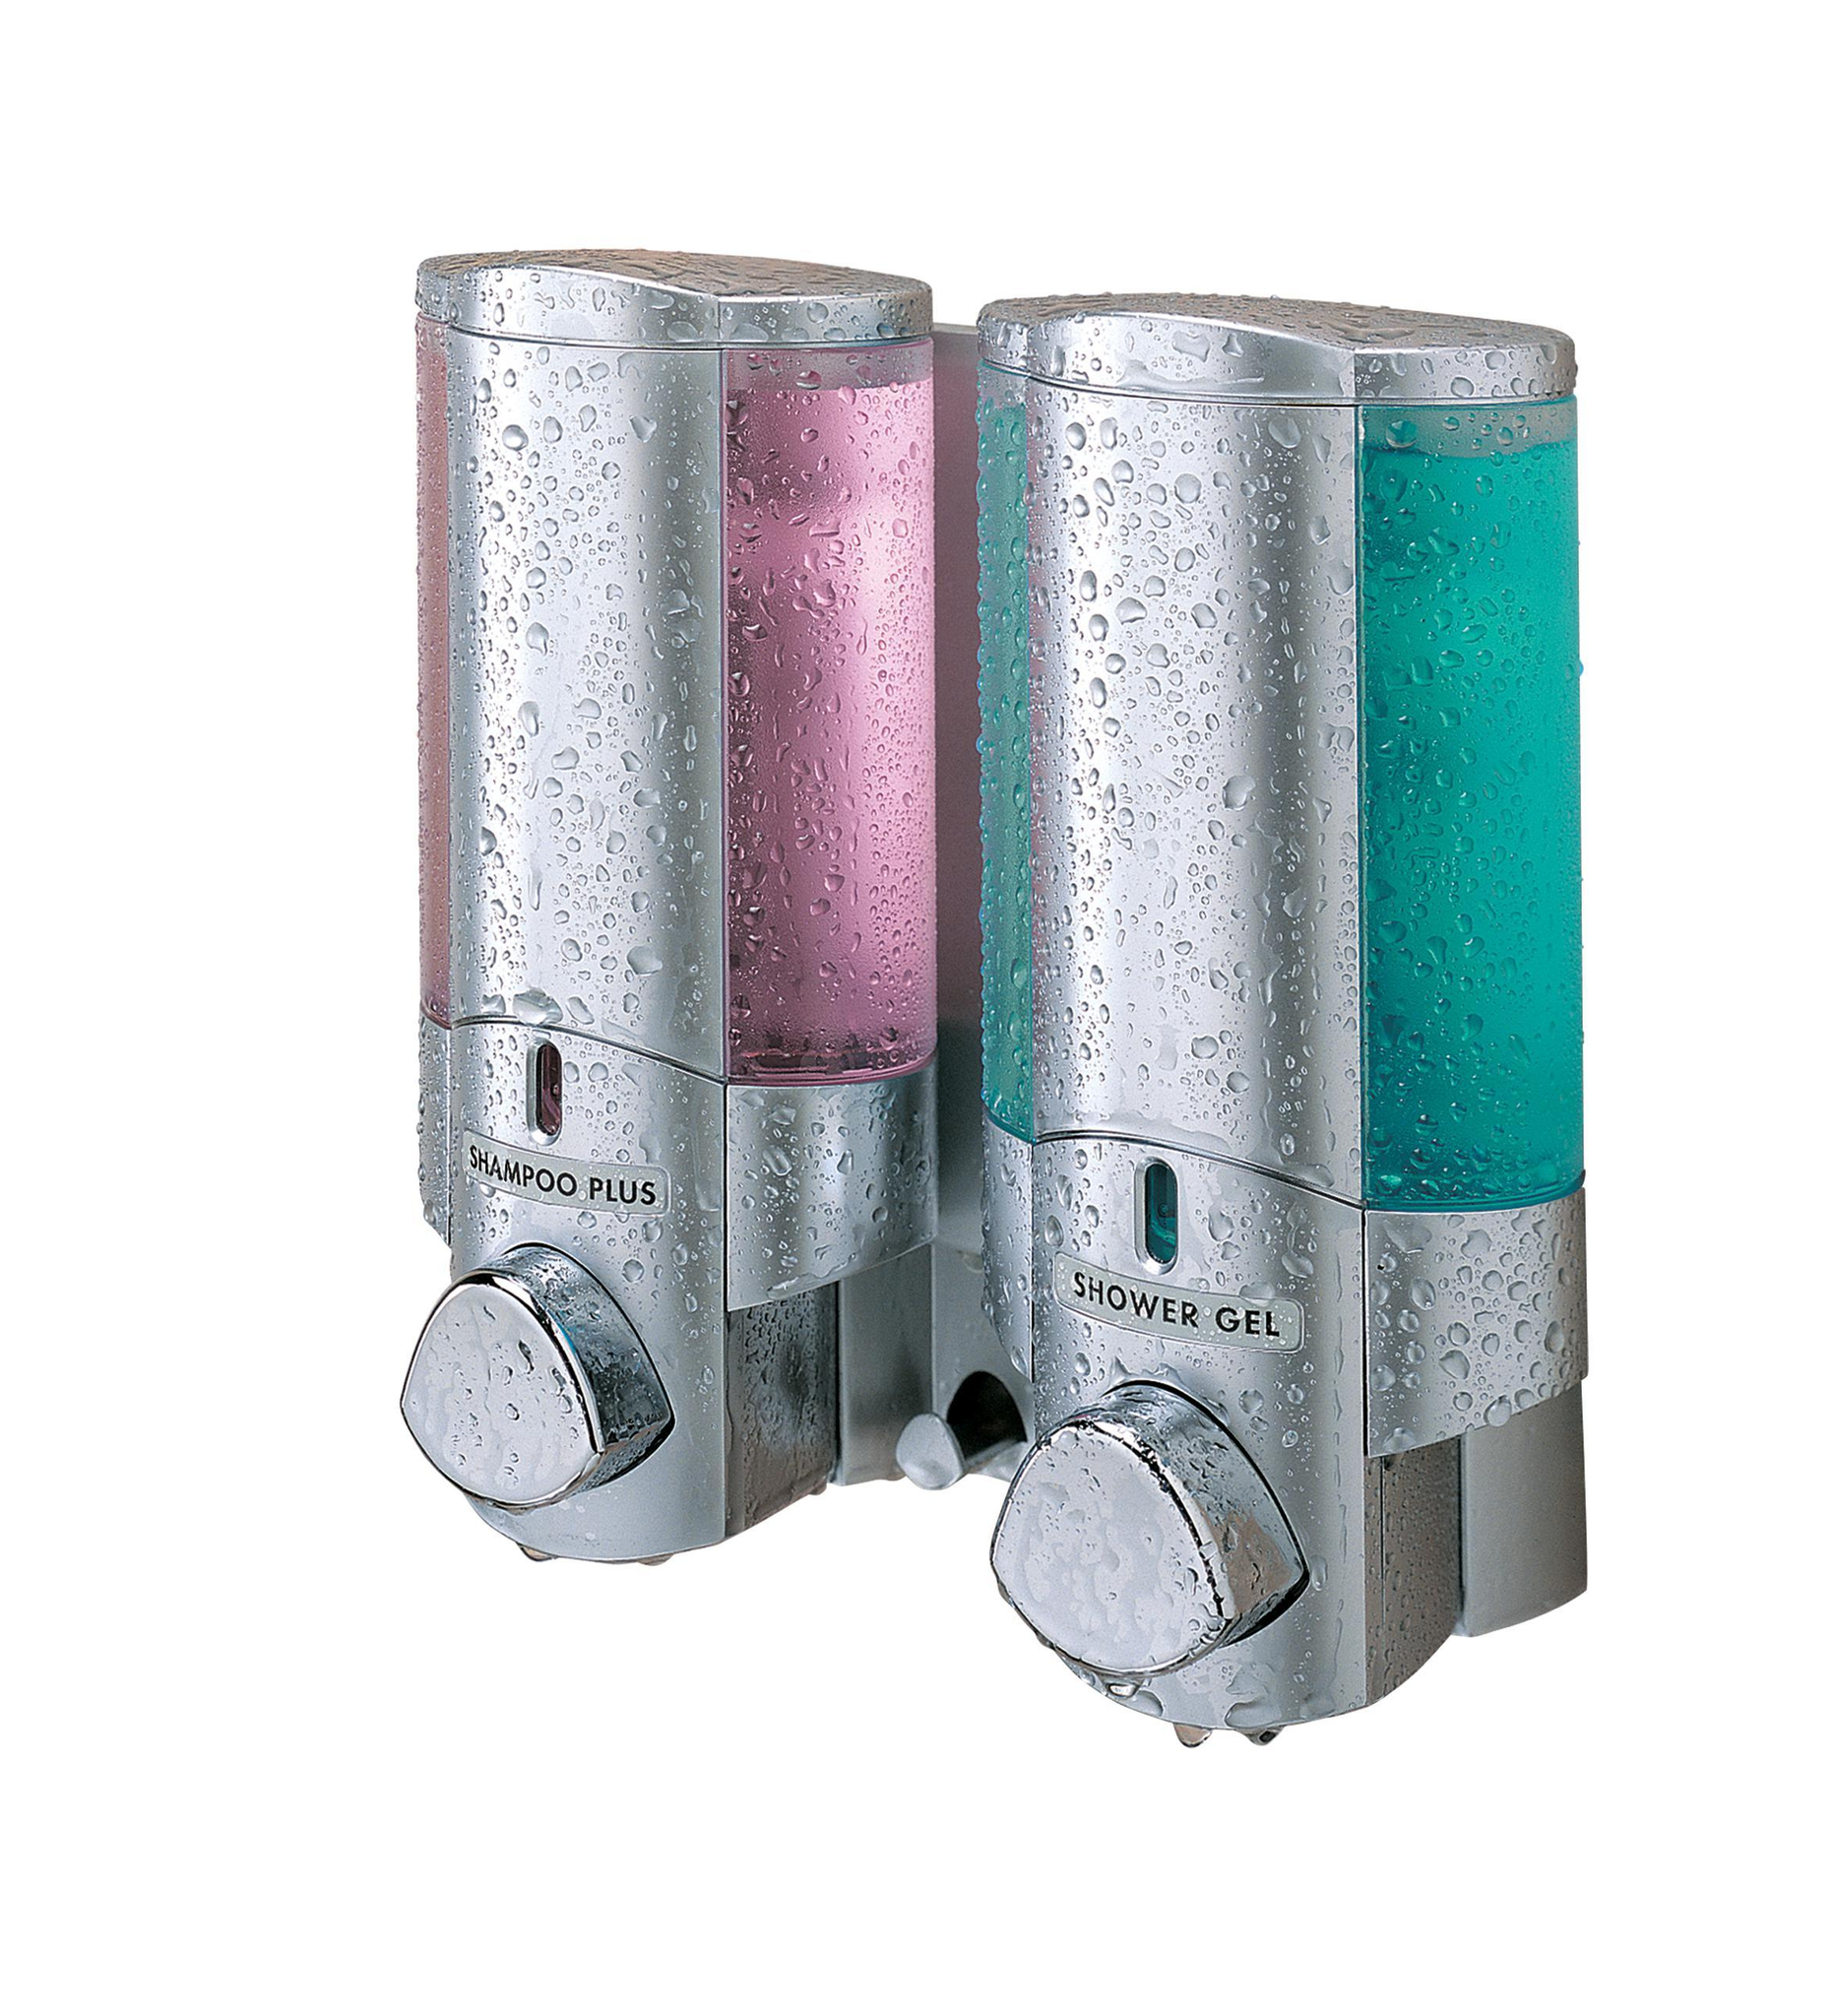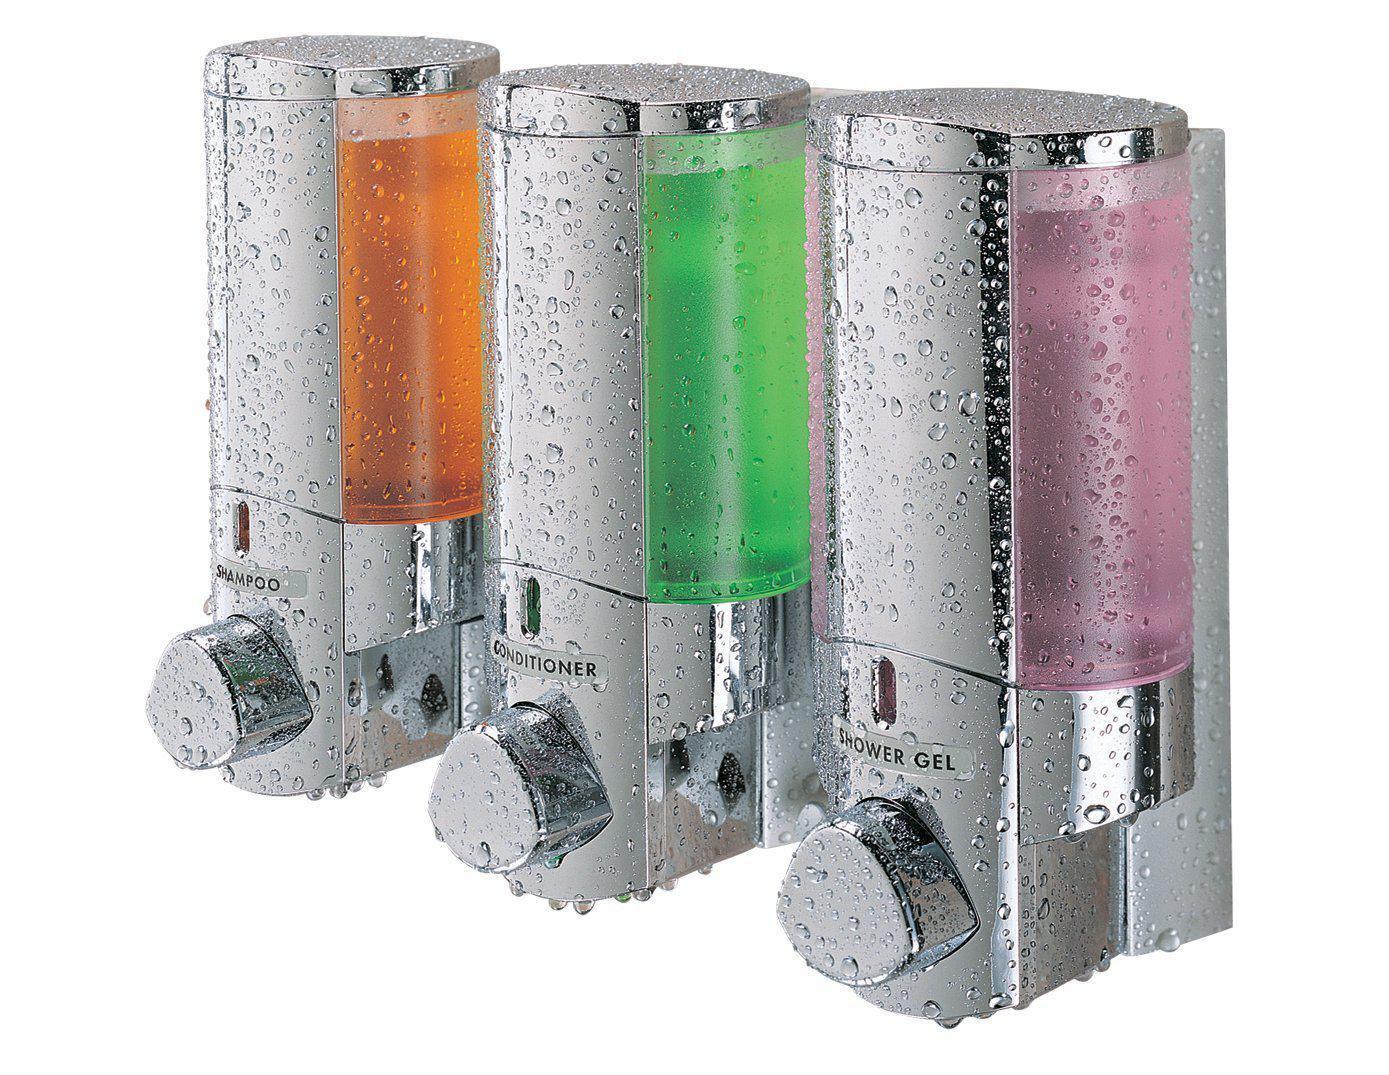The first image is the image on the left, the second image is the image on the right. Considering the images on both sides, is "There are three dispensers in the image on the right." valid? Answer yes or no. Yes. The first image is the image on the left, the second image is the image on the right. Examine the images to the left and right. Is the description "Five bathroom dispensers are divided into groups of two and three, each grouping having at least one liquid color in common with the other." accurate? Answer yes or no. Yes. 